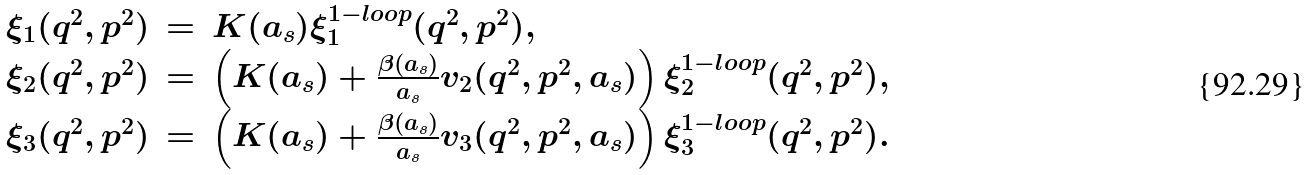<formula> <loc_0><loc_0><loc_500><loc_500>\begin{array} { r c l } \xi _ { 1 } ( q ^ { 2 } , p ^ { 2 } ) & = & K ( a _ { s } ) \xi _ { 1 } ^ { 1 - l o o p } ( q ^ { 2 } , p ^ { 2 } ) , \\ \xi _ { 2 } ( q ^ { 2 } , p ^ { 2 } ) & = & \left ( K ( a _ { s } ) + \frac { \beta ( a _ { s } ) } { a _ { s } } v _ { 2 } ( q ^ { 2 } , p ^ { 2 } , a _ { s } ) \right ) \xi _ { 2 } ^ { 1 - l o o p } ( q ^ { 2 } , p ^ { 2 } ) , \\ \xi _ { 3 } ( q ^ { 2 } , p ^ { 2 } ) & = & \left ( K ( a _ { s } ) + \frac { \beta ( a _ { s } ) } { a _ { s } } v _ { 3 } ( q ^ { 2 } , p ^ { 2 } , a _ { s } ) \right ) \xi _ { 3 } ^ { 1 - l o o p } ( q ^ { 2 } , p ^ { 2 } ) . \end{array}</formula> 